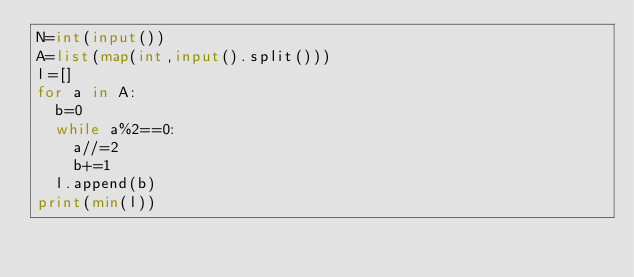<code> <loc_0><loc_0><loc_500><loc_500><_Python_>N=int(input())
A=list(map(int,input().split()))
l=[]
for a in A:
  b=0
  while a%2==0:
    a//=2
  	b+=1
  l.append(b)
print(min(l))</code> 